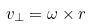Convert formula to latex. <formula><loc_0><loc_0><loc_500><loc_500>v _ { \perp } = { \omega } \times r</formula> 